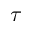Convert formula to latex. <formula><loc_0><loc_0><loc_500><loc_500>\tau</formula> 